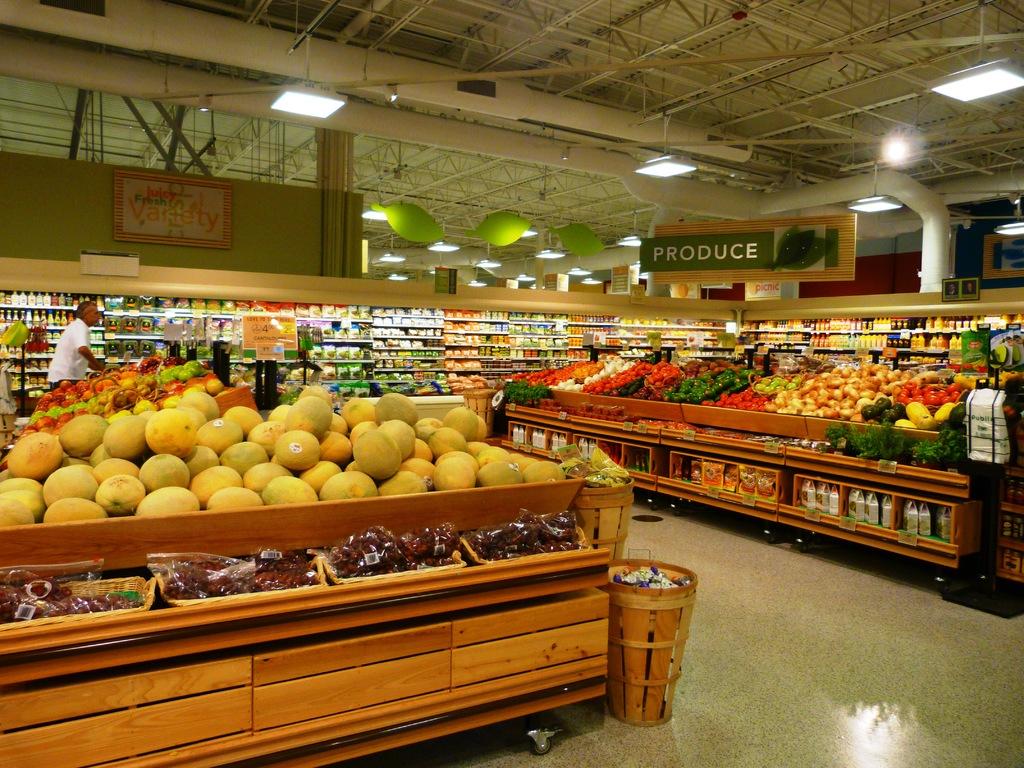What does this area of the store sell?
Your response must be concise. Produce. What is written on the sign to the left?
Make the answer very short. Juicy fresh variety. 